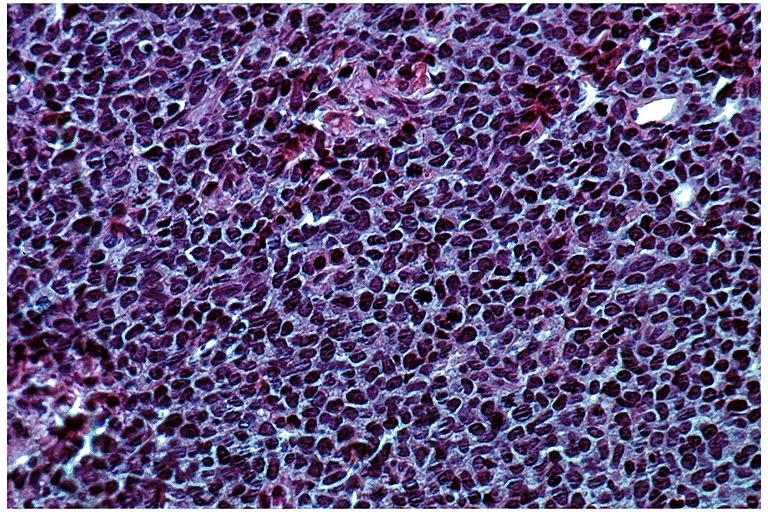does this image show lymphoma?
Answer the question using a single word or phrase. Yes 